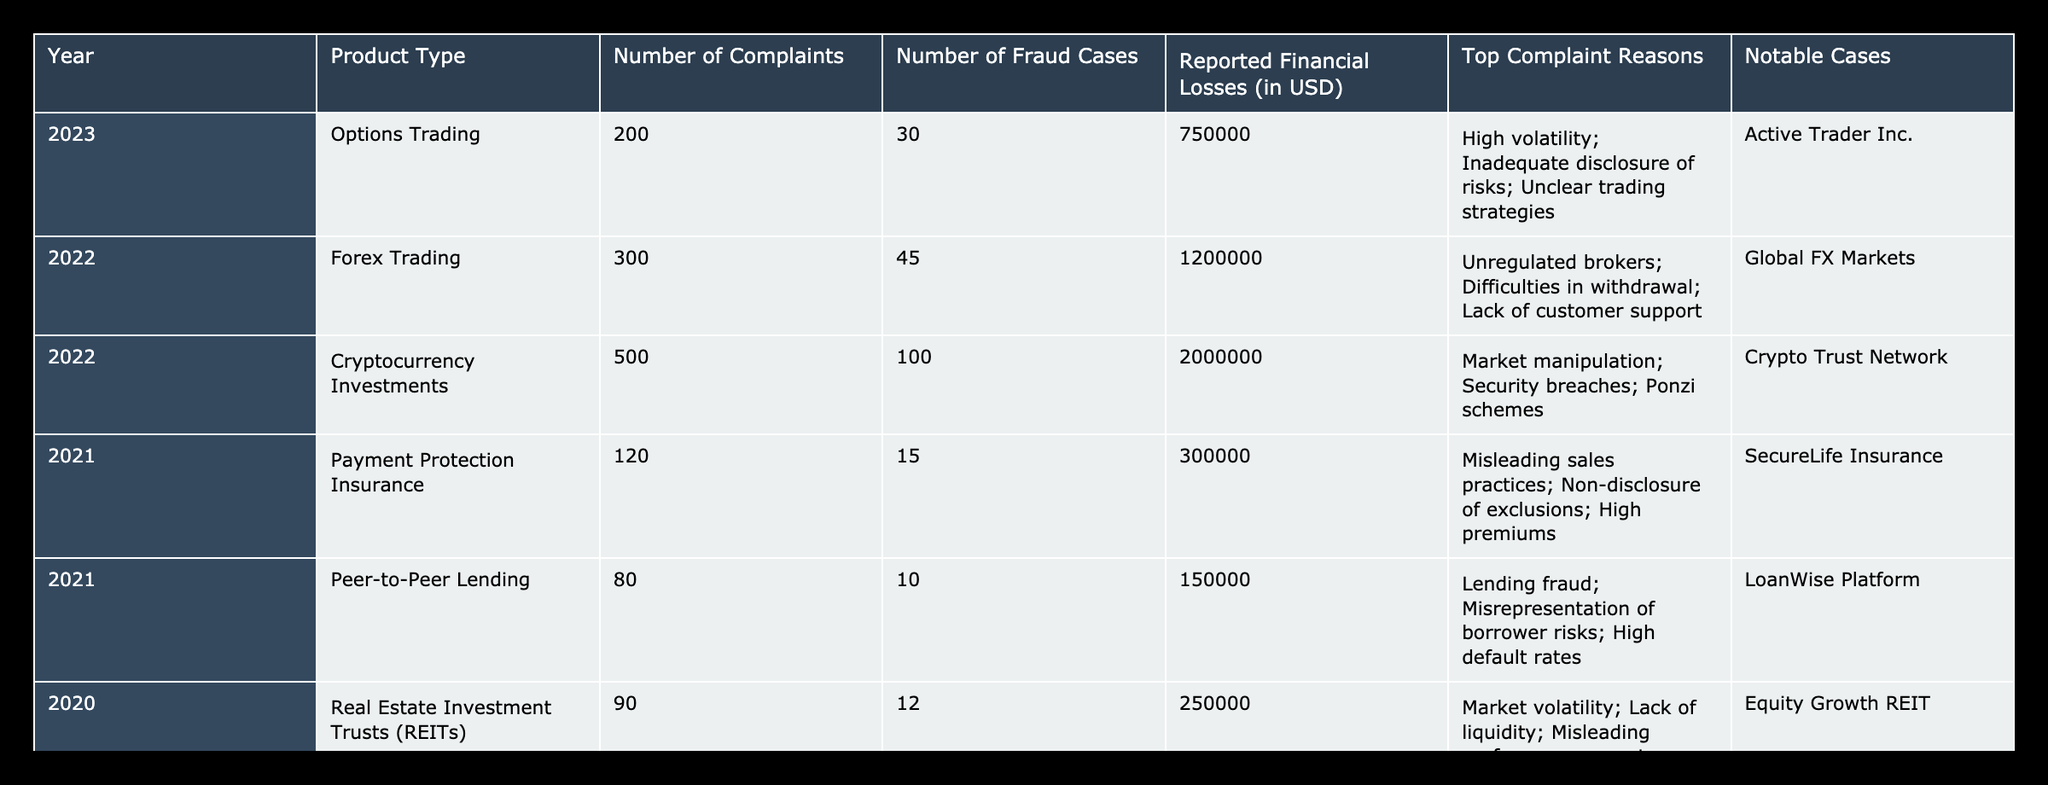What is the highest number of consumer complaints recorded in a single year? Looking at the "Number of Complaints" column, the highest value is 600, which corresponds to the year 2019 for High-Yield Investment Programs.
Answer: 600 In what year did the most fraud cases occur, and how many were there? By reviewing the "Number of Fraud Cases" column, 200 is the highest number of fraud cases recorded, which occurred in the year 2019 for High-Yield Investment Programs.
Answer: 2019, 200 What was the total reported financial loss across all products in 2022? To find the total reported financial losses for 2022, we add the reported financial losses of Forex Trading (1,200,000) and Cryptocurrency Investments (2,000,000). Therefore, the total is 1,200,000 + 2,000,000 = 3,200,000.
Answer: 3,200,000 Is there any product type that has a higher number of complaints than fraud cases in 2021? In 2021, Payment Protection Insurance had 120 complaints and 15 fraud cases, and Peer-to-Peer Lending had 80 complaints and 10 fraud cases. Both have higher complaints than fraud cases.
Answer: Yes Which product type had the highest reported financial losses in 2019, and what were those losses? Examining the "Reported Financial Losses" column for 2019, High-Yield Investment Programs show the highest loss of 3,500,000 USD.
Answer: High-Yield Investment Programs, 3,500,000 What is the average number of fraud cases for the years recorded in the table? To calculate the average, we take the total number of fraud cases (30 + 45 + 100 + 15 + 10 + 12 + 80 + 200 + 20) = 512, then divide by the number of years (9), yielding an average of about 56.89 cases per year.
Answer: Approximately 56.89 Did any product type in 2020 record more than 100 complaints? Checking the "Number of Complaints" column for 2020, both Real Estate Investment Trusts (90) and Initial Coin Offerings (350) are present. Only Initial Coin Offerings exceeded 100 complaints.
Answer: Yes Which product type experienced the most notable cases, and what was the name of the notable entity? In the 2022 row for Cryptocurrency Investments, the notable case mentioned is Crypto Trust Network, which had the most notable cases listed in the table.
Answer: Cryptocurrency Investments, Crypto Trust Network 